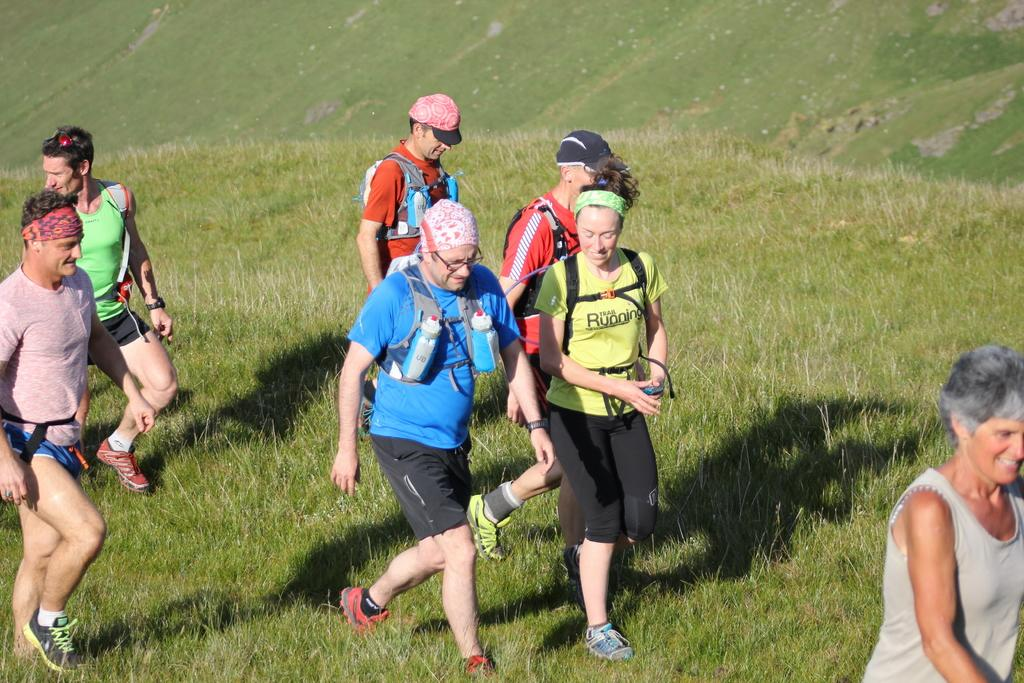What is the setting of the image? The image is an outside view. Who or what can be seen in the image? There are people in the image. What are the people wearing that are visible in the image? The people are wearing bags. What are the people doing in the image? The people are walking on the ground. In which direction are the people walking in the image? The people are walking towards the right side. What type of surface are the people walking on in the image? There is grass on the ground. What type of picture is hanging on the wall in the image? There is no wall or picture visible in the image; it is an outside view with people walking on grass. What type of spoon can be seen in the hands of the people in the image? There are no spoons visible in the image; the people are wearing bags and walking on grass. 